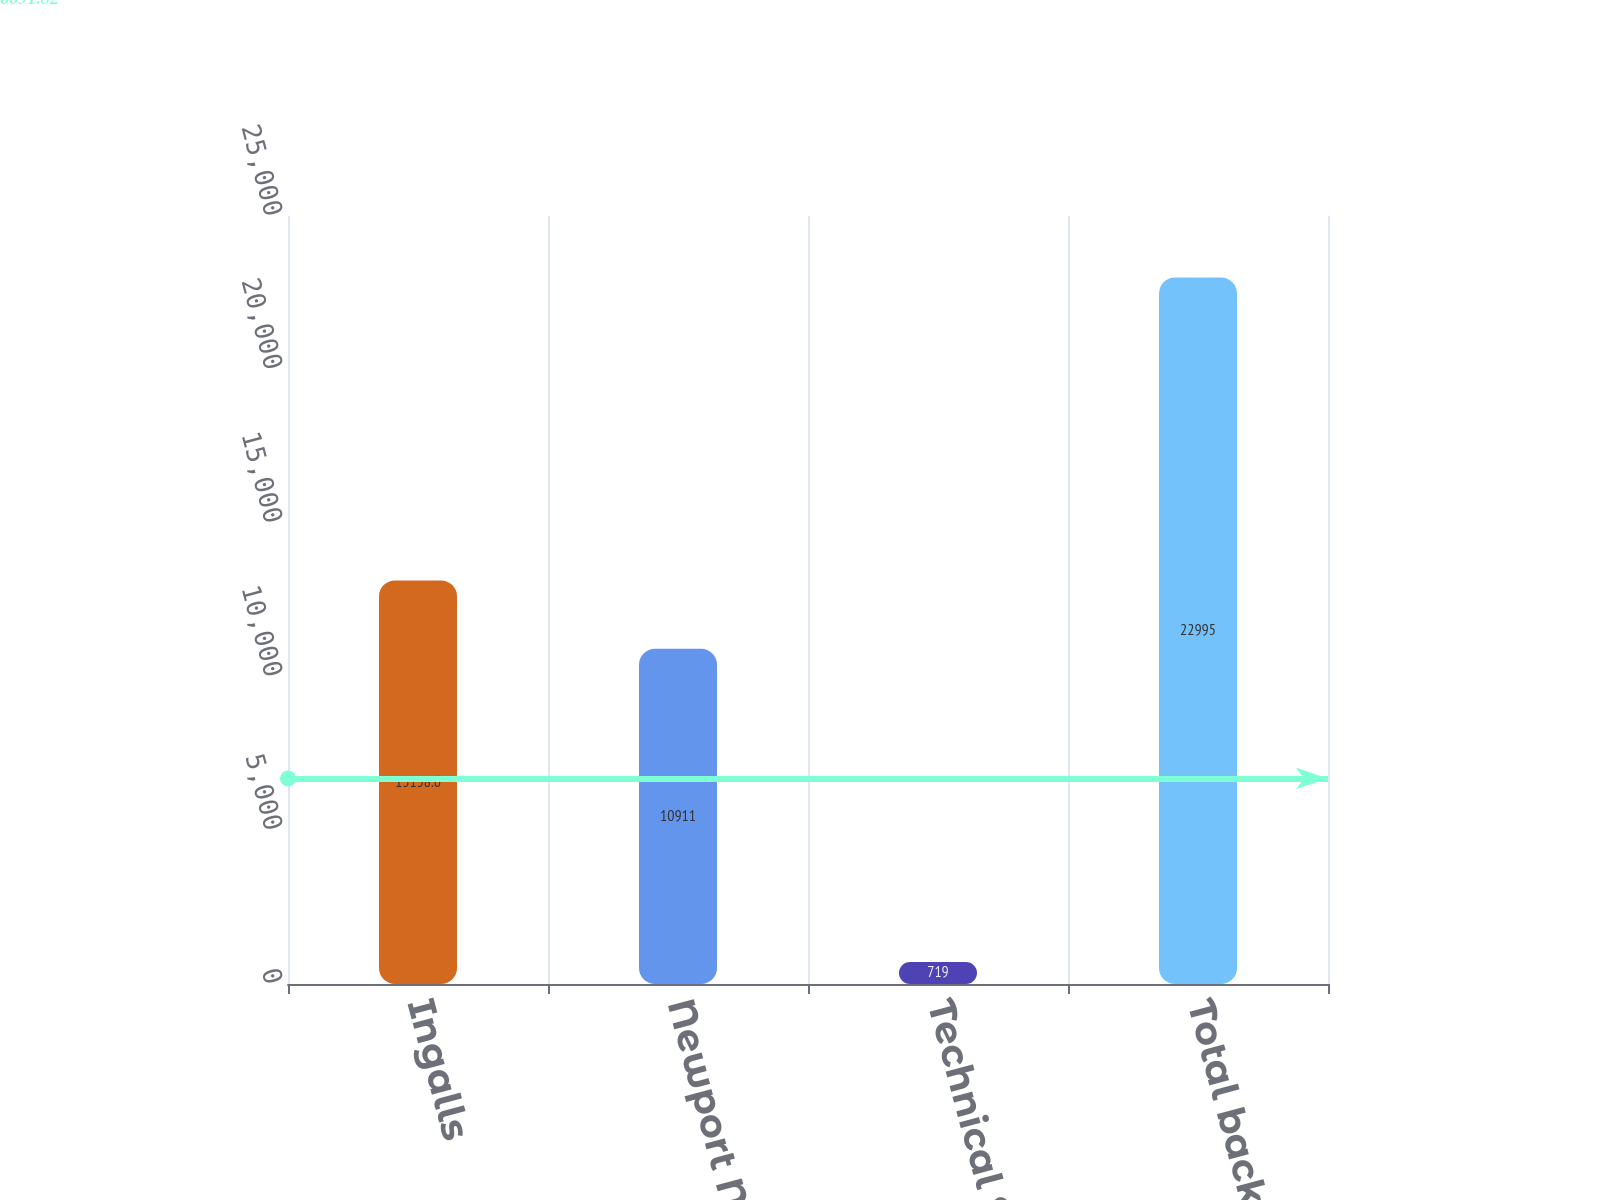Convert chart. <chart><loc_0><loc_0><loc_500><loc_500><bar_chart><fcel>Ingalls<fcel>Newport News<fcel>Technical Solutions<fcel>Total backlog<nl><fcel>13138.6<fcel>10911<fcel>719<fcel>22995<nl></chart> 